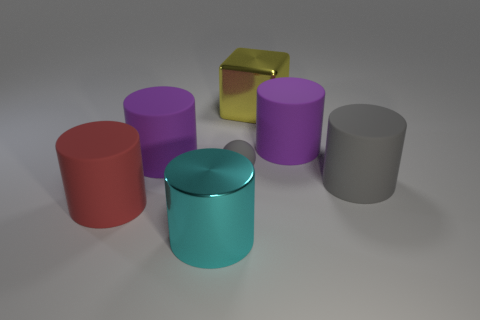Subtract all large gray cylinders. How many cylinders are left? 4 Subtract all purple spheres. How many purple cylinders are left? 2 Add 2 big green shiny cylinders. How many objects exist? 9 Subtract all red cylinders. How many cylinders are left? 4 Subtract 1 cylinders. How many cylinders are left? 4 Subtract all balls. How many objects are left? 6 Add 6 tiny things. How many tiny things are left? 7 Add 7 big yellow shiny blocks. How many big yellow shiny blocks exist? 8 Subtract 0 green balls. How many objects are left? 7 Subtract all blue blocks. Subtract all cyan balls. How many blocks are left? 1 